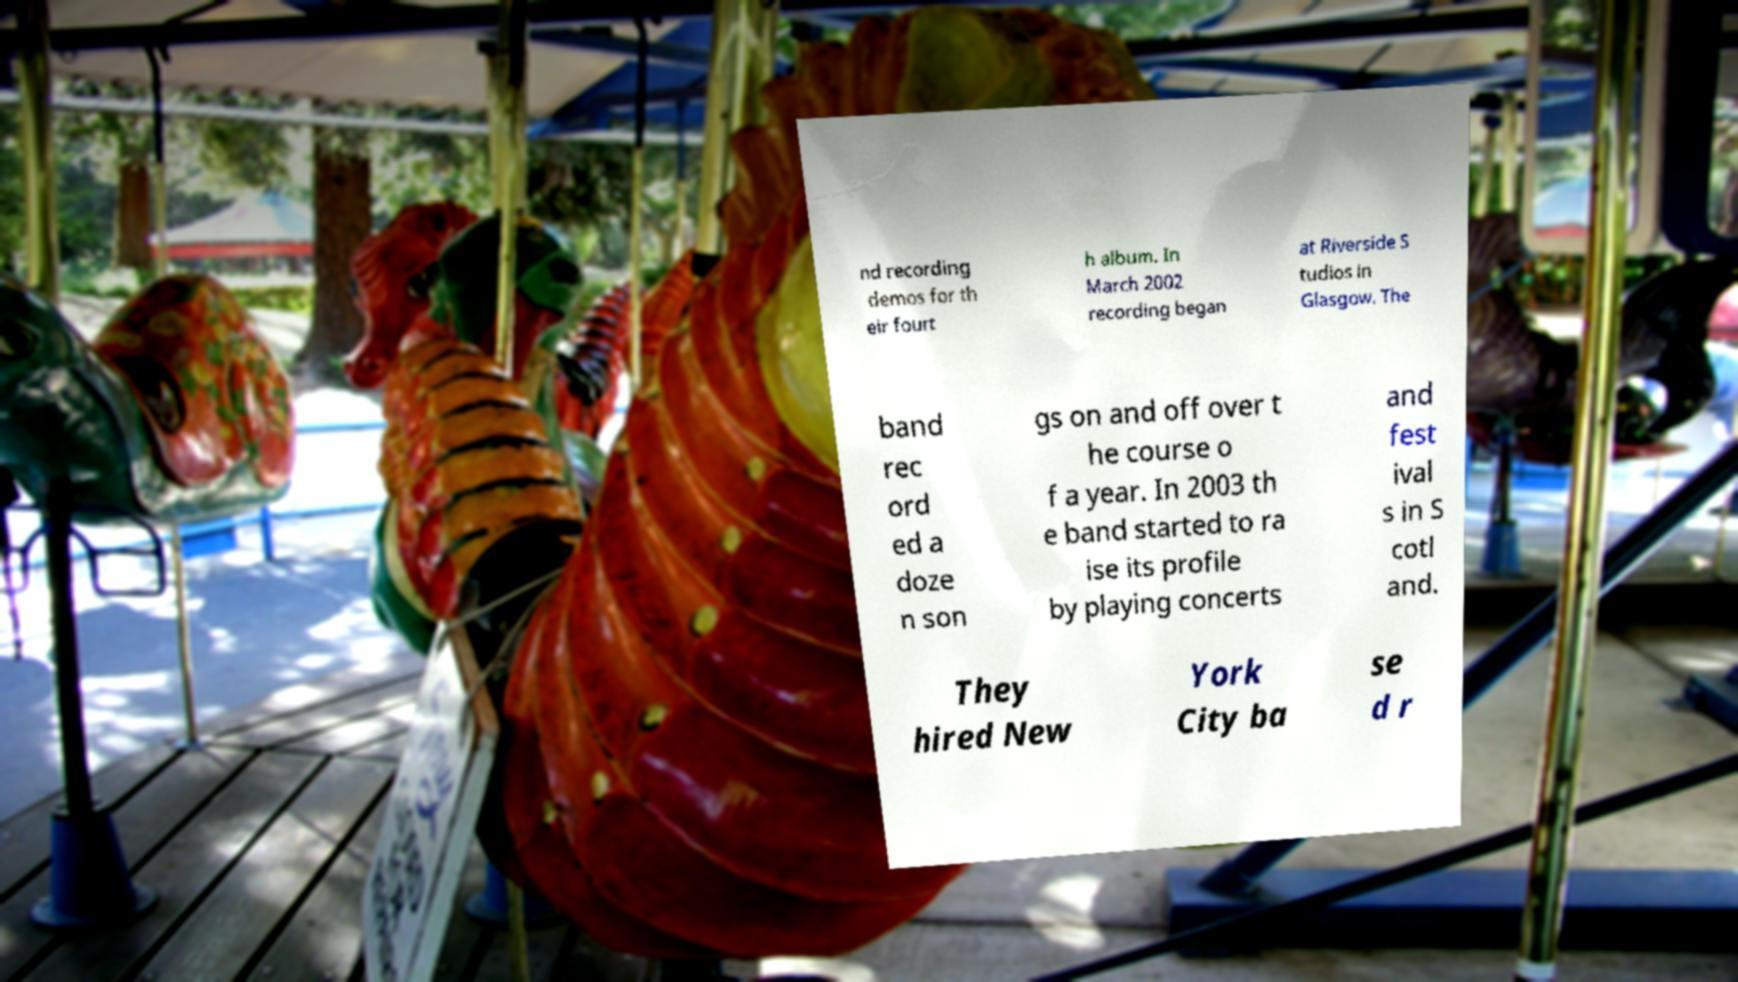Please identify and transcribe the text found in this image. nd recording demos for th eir fourt h album. In March 2002 recording began at Riverside S tudios in Glasgow. The band rec ord ed a doze n son gs on and off over t he course o f a year. In 2003 th e band started to ra ise its profile by playing concerts and fest ival s in S cotl and. They hired New York City ba se d r 